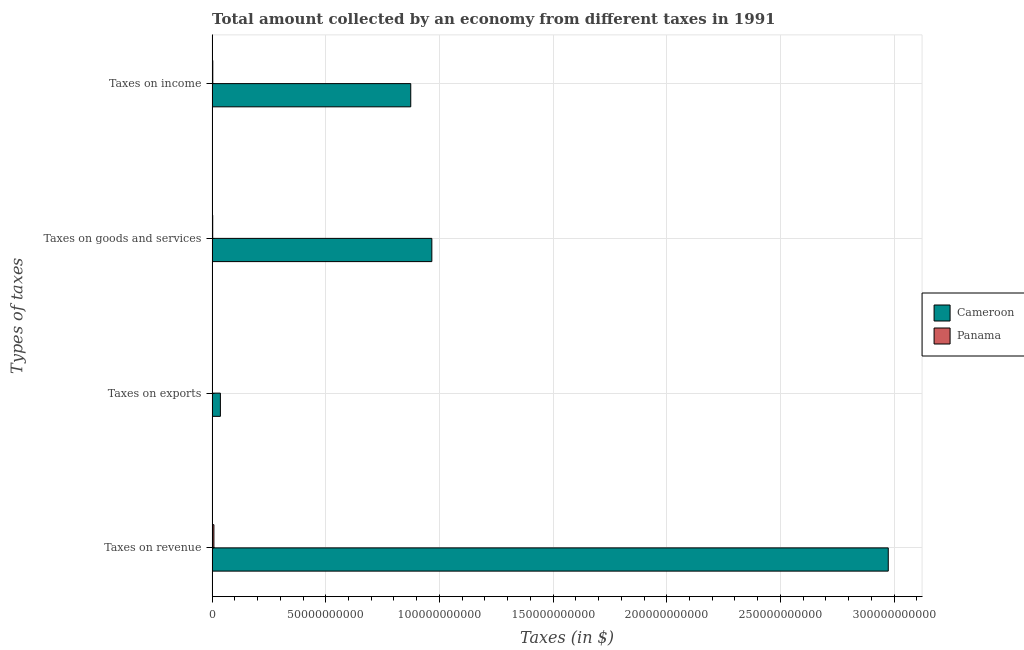Are the number of bars per tick equal to the number of legend labels?
Your answer should be very brief. Yes. Are the number of bars on each tick of the Y-axis equal?
Your response must be concise. Yes. How many bars are there on the 3rd tick from the top?
Keep it short and to the point. 2. What is the label of the 4th group of bars from the top?
Your answer should be compact. Taxes on revenue. What is the amount collected as tax on income in Cameroon?
Make the answer very short. 8.74e+1. Across all countries, what is the maximum amount collected as tax on revenue?
Make the answer very short. 2.97e+11. Across all countries, what is the minimum amount collected as tax on exports?
Offer a very short reply. 1.62e+07. In which country was the amount collected as tax on goods maximum?
Give a very brief answer. Cameroon. In which country was the amount collected as tax on income minimum?
Keep it short and to the point. Panama. What is the total amount collected as tax on revenue in the graph?
Make the answer very short. 2.98e+11. What is the difference between the amount collected as tax on income in Panama and that in Cameroon?
Offer a very short reply. -8.71e+1. What is the difference between the amount collected as tax on revenue in Cameroon and the amount collected as tax on income in Panama?
Give a very brief answer. 2.97e+11. What is the average amount collected as tax on income per country?
Your response must be concise. 4.38e+1. What is the difference between the amount collected as tax on revenue and amount collected as tax on income in Cameroon?
Make the answer very short. 2.10e+11. In how many countries, is the amount collected as tax on exports greater than 30000000000 $?
Offer a very short reply. 0. What is the ratio of the amount collected as tax on income in Cameroon to that in Panama?
Offer a very short reply. 291.85. What is the difference between the highest and the second highest amount collected as tax on goods?
Your answer should be compact. 9.64e+1. What is the difference between the highest and the lowest amount collected as tax on income?
Give a very brief answer. 8.71e+1. What does the 2nd bar from the top in Taxes on exports represents?
Provide a succinct answer. Cameroon. What does the 1st bar from the bottom in Taxes on exports represents?
Your response must be concise. Cameroon. How many bars are there?
Ensure brevity in your answer.  8. Are all the bars in the graph horizontal?
Keep it short and to the point. Yes. What is the difference between two consecutive major ticks on the X-axis?
Your response must be concise. 5.00e+1. Does the graph contain any zero values?
Your answer should be very brief. No. Does the graph contain grids?
Provide a succinct answer. Yes. How are the legend labels stacked?
Offer a very short reply. Vertical. What is the title of the graph?
Ensure brevity in your answer.  Total amount collected by an economy from different taxes in 1991. What is the label or title of the X-axis?
Offer a terse response. Taxes (in $). What is the label or title of the Y-axis?
Ensure brevity in your answer.  Types of taxes. What is the Taxes (in $) of Cameroon in Taxes on revenue?
Your answer should be compact. 2.97e+11. What is the Taxes (in $) of Panama in Taxes on revenue?
Give a very brief answer. 7.87e+08. What is the Taxes (in $) in Cameroon in Taxes on exports?
Make the answer very short. 3.64e+09. What is the Taxes (in $) of Panama in Taxes on exports?
Give a very brief answer. 1.62e+07. What is the Taxes (in $) of Cameroon in Taxes on goods and services?
Make the answer very short. 9.67e+1. What is the Taxes (in $) in Panama in Taxes on goods and services?
Keep it short and to the point. 2.60e+08. What is the Taxes (in $) of Cameroon in Taxes on income?
Provide a short and direct response. 8.74e+1. What is the Taxes (in $) in Panama in Taxes on income?
Provide a succinct answer. 2.99e+08. Across all Types of taxes, what is the maximum Taxes (in $) of Cameroon?
Your response must be concise. 2.97e+11. Across all Types of taxes, what is the maximum Taxes (in $) of Panama?
Your answer should be compact. 7.87e+08. Across all Types of taxes, what is the minimum Taxes (in $) of Cameroon?
Your response must be concise. 3.64e+09. Across all Types of taxes, what is the minimum Taxes (in $) of Panama?
Give a very brief answer. 1.62e+07. What is the total Taxes (in $) of Cameroon in the graph?
Offer a very short reply. 4.85e+11. What is the total Taxes (in $) in Panama in the graph?
Provide a succinct answer. 1.36e+09. What is the difference between the Taxes (in $) in Cameroon in Taxes on revenue and that in Taxes on exports?
Make the answer very short. 2.94e+11. What is the difference between the Taxes (in $) in Panama in Taxes on revenue and that in Taxes on exports?
Provide a short and direct response. 7.70e+08. What is the difference between the Taxes (in $) in Cameroon in Taxes on revenue and that in Taxes on goods and services?
Your answer should be very brief. 2.01e+11. What is the difference between the Taxes (in $) in Panama in Taxes on revenue and that in Taxes on goods and services?
Provide a succinct answer. 5.27e+08. What is the difference between the Taxes (in $) of Cameroon in Taxes on revenue and that in Taxes on income?
Your answer should be very brief. 2.10e+11. What is the difference between the Taxes (in $) in Panama in Taxes on revenue and that in Taxes on income?
Your response must be concise. 4.87e+08. What is the difference between the Taxes (in $) of Cameroon in Taxes on exports and that in Taxes on goods and services?
Make the answer very short. -9.30e+1. What is the difference between the Taxes (in $) of Panama in Taxes on exports and that in Taxes on goods and services?
Offer a very short reply. -2.43e+08. What is the difference between the Taxes (in $) of Cameroon in Taxes on exports and that in Taxes on income?
Your answer should be very brief. -8.37e+1. What is the difference between the Taxes (in $) of Panama in Taxes on exports and that in Taxes on income?
Give a very brief answer. -2.83e+08. What is the difference between the Taxes (in $) in Cameroon in Taxes on goods and services and that in Taxes on income?
Keep it short and to the point. 9.28e+09. What is the difference between the Taxes (in $) of Panama in Taxes on goods and services and that in Taxes on income?
Give a very brief answer. -3.98e+07. What is the difference between the Taxes (in $) in Cameroon in Taxes on revenue and the Taxes (in $) in Panama in Taxes on exports?
Ensure brevity in your answer.  2.97e+11. What is the difference between the Taxes (in $) in Cameroon in Taxes on revenue and the Taxes (in $) in Panama in Taxes on goods and services?
Offer a terse response. 2.97e+11. What is the difference between the Taxes (in $) of Cameroon in Taxes on revenue and the Taxes (in $) of Panama in Taxes on income?
Make the answer very short. 2.97e+11. What is the difference between the Taxes (in $) in Cameroon in Taxes on exports and the Taxes (in $) in Panama in Taxes on goods and services?
Provide a short and direct response. 3.38e+09. What is the difference between the Taxes (in $) in Cameroon in Taxes on exports and the Taxes (in $) in Panama in Taxes on income?
Offer a very short reply. 3.34e+09. What is the difference between the Taxes (in $) in Cameroon in Taxes on goods and services and the Taxes (in $) in Panama in Taxes on income?
Your answer should be very brief. 9.64e+1. What is the average Taxes (in $) of Cameroon per Types of taxes?
Give a very brief answer. 1.21e+11. What is the average Taxes (in $) of Panama per Types of taxes?
Provide a short and direct response. 3.40e+08. What is the difference between the Taxes (in $) of Cameroon and Taxes (in $) of Panama in Taxes on revenue?
Provide a succinct answer. 2.97e+11. What is the difference between the Taxes (in $) in Cameroon and Taxes (in $) in Panama in Taxes on exports?
Your response must be concise. 3.62e+09. What is the difference between the Taxes (in $) of Cameroon and Taxes (in $) of Panama in Taxes on goods and services?
Ensure brevity in your answer.  9.64e+1. What is the difference between the Taxes (in $) in Cameroon and Taxes (in $) in Panama in Taxes on income?
Your answer should be compact. 8.71e+1. What is the ratio of the Taxes (in $) of Cameroon in Taxes on revenue to that in Taxes on exports?
Keep it short and to the point. 81.72. What is the ratio of the Taxes (in $) in Panama in Taxes on revenue to that in Taxes on exports?
Your answer should be compact. 48.56. What is the ratio of the Taxes (in $) in Cameroon in Taxes on revenue to that in Taxes on goods and services?
Your answer should be very brief. 3.08. What is the ratio of the Taxes (in $) in Panama in Taxes on revenue to that in Taxes on goods and services?
Your answer should be compact. 3.03. What is the ratio of the Taxes (in $) of Cameroon in Taxes on revenue to that in Taxes on income?
Your answer should be very brief. 3.4. What is the ratio of the Taxes (in $) of Panama in Taxes on revenue to that in Taxes on income?
Offer a very short reply. 2.63. What is the ratio of the Taxes (in $) of Cameroon in Taxes on exports to that in Taxes on goods and services?
Provide a short and direct response. 0.04. What is the ratio of the Taxes (in $) in Panama in Taxes on exports to that in Taxes on goods and services?
Offer a very short reply. 0.06. What is the ratio of the Taxes (in $) in Cameroon in Taxes on exports to that in Taxes on income?
Ensure brevity in your answer.  0.04. What is the ratio of the Taxes (in $) in Panama in Taxes on exports to that in Taxes on income?
Your response must be concise. 0.05. What is the ratio of the Taxes (in $) of Cameroon in Taxes on goods and services to that in Taxes on income?
Keep it short and to the point. 1.11. What is the ratio of the Taxes (in $) in Panama in Taxes on goods and services to that in Taxes on income?
Keep it short and to the point. 0.87. What is the difference between the highest and the second highest Taxes (in $) in Cameroon?
Ensure brevity in your answer.  2.01e+11. What is the difference between the highest and the second highest Taxes (in $) in Panama?
Provide a succinct answer. 4.87e+08. What is the difference between the highest and the lowest Taxes (in $) in Cameroon?
Offer a terse response. 2.94e+11. What is the difference between the highest and the lowest Taxes (in $) of Panama?
Make the answer very short. 7.70e+08. 